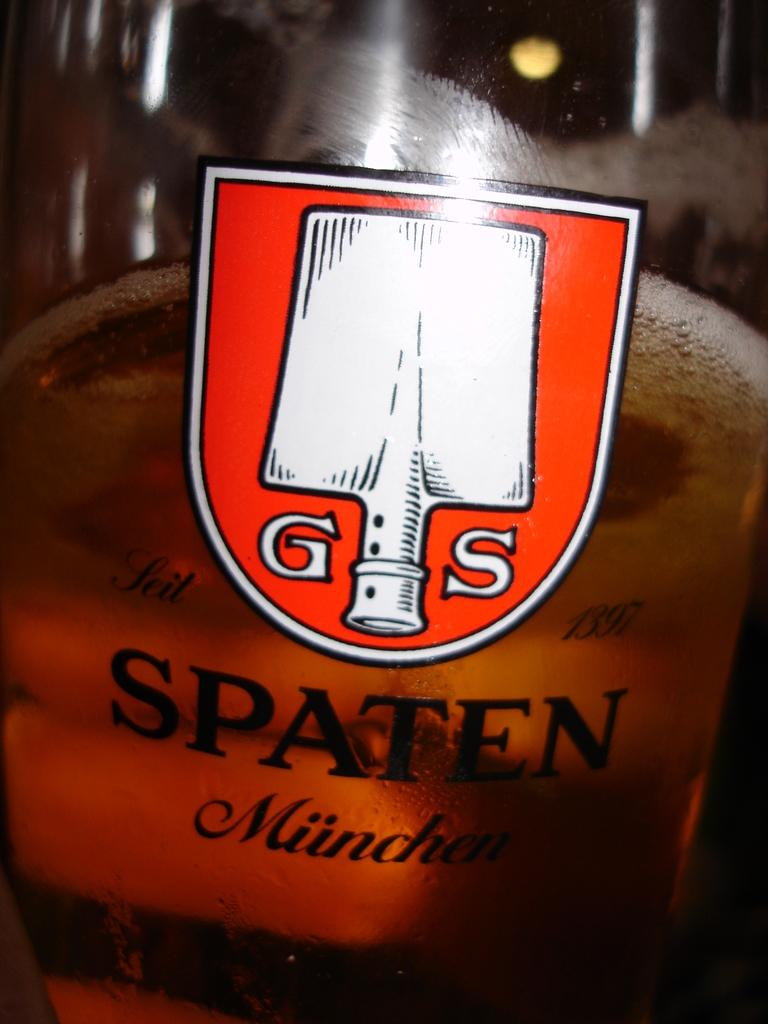<image>
Relay a brief, clear account of the picture shown. The logo for Spaten Munchen is displayed on a pint glass. 